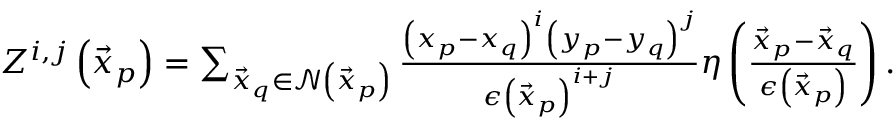<formula> <loc_0><loc_0><loc_500><loc_500>\begin{array} { r } { Z ^ { i , j } \left ( \vec { x } _ { p } \right ) = \sum _ { \vec { x } _ { q } \in \mathcal { N } \left ( \vec { x } _ { p } \right ) } \frac { \left ( x _ { p } - x _ { q } \right ) ^ { i } \left ( y _ { p } - y _ { q } \right ) ^ { j } } { \epsilon \left ( \vec { x } _ { p } \right ) ^ { i + j } } \eta \left ( \frac { \vec { x } _ { p } - \vec { x } _ { q } } { \epsilon \left ( \vec { x } _ { p } \right ) } \right ) . } \end{array}</formula> 